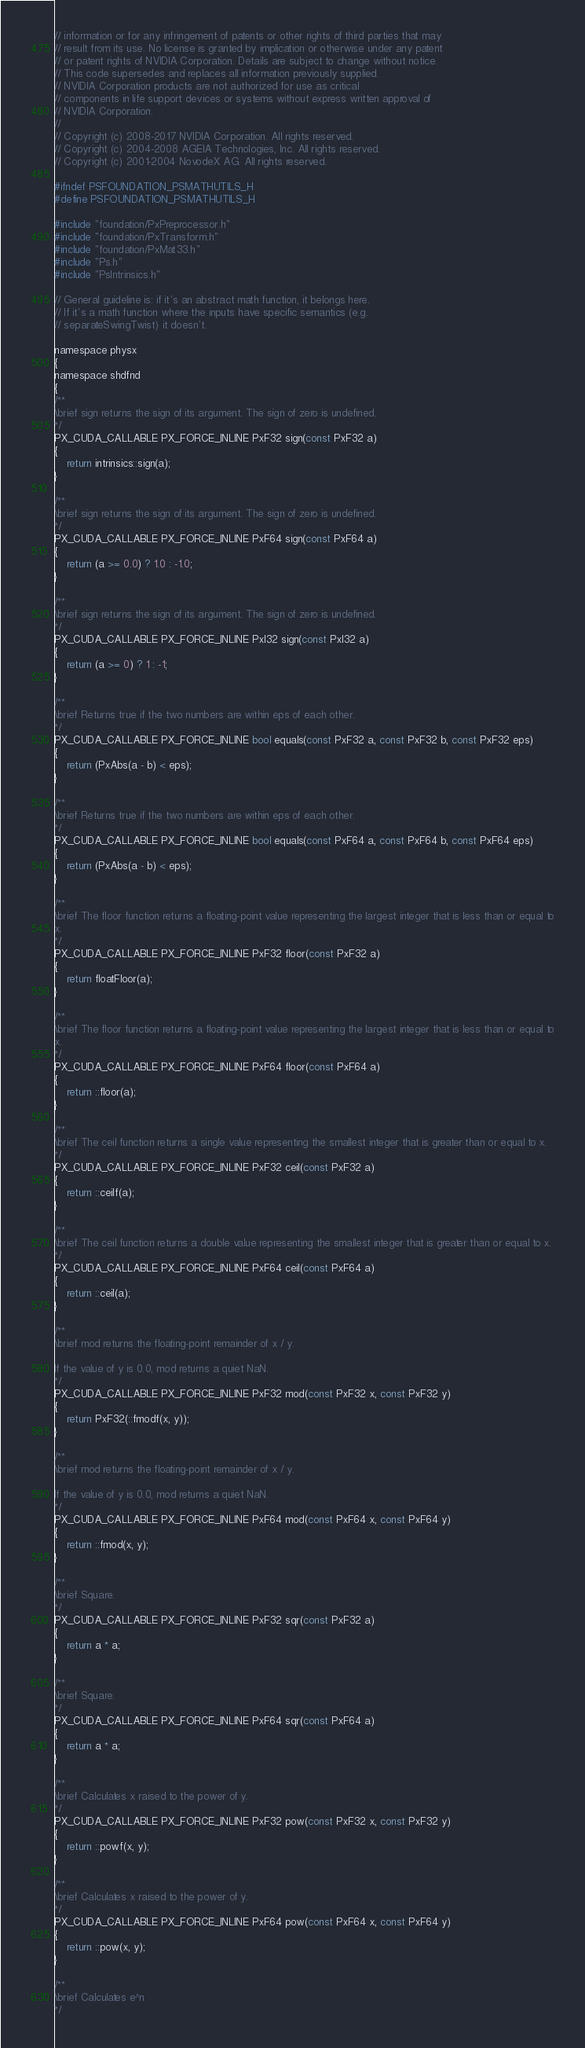Convert code to text. <code><loc_0><loc_0><loc_500><loc_500><_C_>// information or for any infringement of patents or other rights of third parties that may
// result from its use. No license is granted by implication or otherwise under any patent
// or patent rights of NVIDIA Corporation. Details are subject to change without notice.
// This code supersedes and replaces all information previously supplied.
// NVIDIA Corporation products are not authorized for use as critical
// components in life support devices or systems without express written approval of
// NVIDIA Corporation.
//
// Copyright (c) 2008-2017 NVIDIA Corporation. All rights reserved.
// Copyright (c) 2004-2008 AGEIA Technologies, Inc. All rights reserved.
// Copyright (c) 2001-2004 NovodeX AG. All rights reserved.

#ifndef PSFOUNDATION_PSMATHUTILS_H
#define PSFOUNDATION_PSMATHUTILS_H

#include "foundation/PxPreprocessor.h"
#include "foundation/PxTransform.h"
#include "foundation/PxMat33.h"
#include "Ps.h"
#include "PsIntrinsics.h"

// General guideline is: if it's an abstract math function, it belongs here.
// If it's a math function where the inputs have specific semantics (e.g.
// separateSwingTwist) it doesn't.

namespace physx
{
namespace shdfnd
{
/**
\brief sign returns the sign of its argument. The sign of zero is undefined.
*/
PX_CUDA_CALLABLE PX_FORCE_INLINE PxF32 sign(const PxF32 a)
{
	return intrinsics::sign(a);
}

/**
\brief sign returns the sign of its argument. The sign of zero is undefined.
*/
PX_CUDA_CALLABLE PX_FORCE_INLINE PxF64 sign(const PxF64 a)
{
	return (a >= 0.0) ? 1.0 : -1.0;
}

/**
\brief sign returns the sign of its argument. The sign of zero is undefined.
*/
PX_CUDA_CALLABLE PX_FORCE_INLINE PxI32 sign(const PxI32 a)
{
	return (a >= 0) ? 1 : -1;
}

/**
\brief Returns true if the two numbers are within eps of each other.
*/
PX_CUDA_CALLABLE PX_FORCE_INLINE bool equals(const PxF32 a, const PxF32 b, const PxF32 eps)
{
	return (PxAbs(a - b) < eps);
}

/**
\brief Returns true if the two numbers are within eps of each other.
*/
PX_CUDA_CALLABLE PX_FORCE_INLINE bool equals(const PxF64 a, const PxF64 b, const PxF64 eps)
{
	return (PxAbs(a - b) < eps);
}

/**
\brief The floor function returns a floating-point value representing the largest integer that is less than or equal to
x.
*/
PX_CUDA_CALLABLE PX_FORCE_INLINE PxF32 floor(const PxF32 a)
{
	return floatFloor(a);
}

/**
\brief The floor function returns a floating-point value representing the largest integer that is less than or equal to
x.
*/
PX_CUDA_CALLABLE PX_FORCE_INLINE PxF64 floor(const PxF64 a)
{
	return ::floor(a);
}

/**
\brief The ceil function returns a single value representing the smallest integer that is greater than or equal to x.
*/
PX_CUDA_CALLABLE PX_FORCE_INLINE PxF32 ceil(const PxF32 a)
{
	return ::ceilf(a);
}

/**
\brief The ceil function returns a double value representing the smallest integer that is greater than or equal to x.
*/
PX_CUDA_CALLABLE PX_FORCE_INLINE PxF64 ceil(const PxF64 a)
{
	return ::ceil(a);
}

/**
\brief mod returns the floating-point remainder of x / y.

If the value of y is 0.0, mod returns a quiet NaN.
*/
PX_CUDA_CALLABLE PX_FORCE_INLINE PxF32 mod(const PxF32 x, const PxF32 y)
{
	return PxF32(::fmodf(x, y));
}

/**
\brief mod returns the floating-point remainder of x / y.

If the value of y is 0.0, mod returns a quiet NaN.
*/
PX_CUDA_CALLABLE PX_FORCE_INLINE PxF64 mod(const PxF64 x, const PxF64 y)
{
	return ::fmod(x, y);
}

/**
\brief Square.
*/
PX_CUDA_CALLABLE PX_FORCE_INLINE PxF32 sqr(const PxF32 a)
{
	return a * a;
}

/**
\brief Square.
*/
PX_CUDA_CALLABLE PX_FORCE_INLINE PxF64 sqr(const PxF64 a)
{
	return a * a;
}

/**
\brief Calculates x raised to the power of y.
*/
PX_CUDA_CALLABLE PX_FORCE_INLINE PxF32 pow(const PxF32 x, const PxF32 y)
{
	return ::powf(x, y);
}

/**
\brief Calculates x raised to the power of y.
*/
PX_CUDA_CALLABLE PX_FORCE_INLINE PxF64 pow(const PxF64 x, const PxF64 y)
{
	return ::pow(x, y);
}

/**
\brief Calculates e^n
*/</code> 